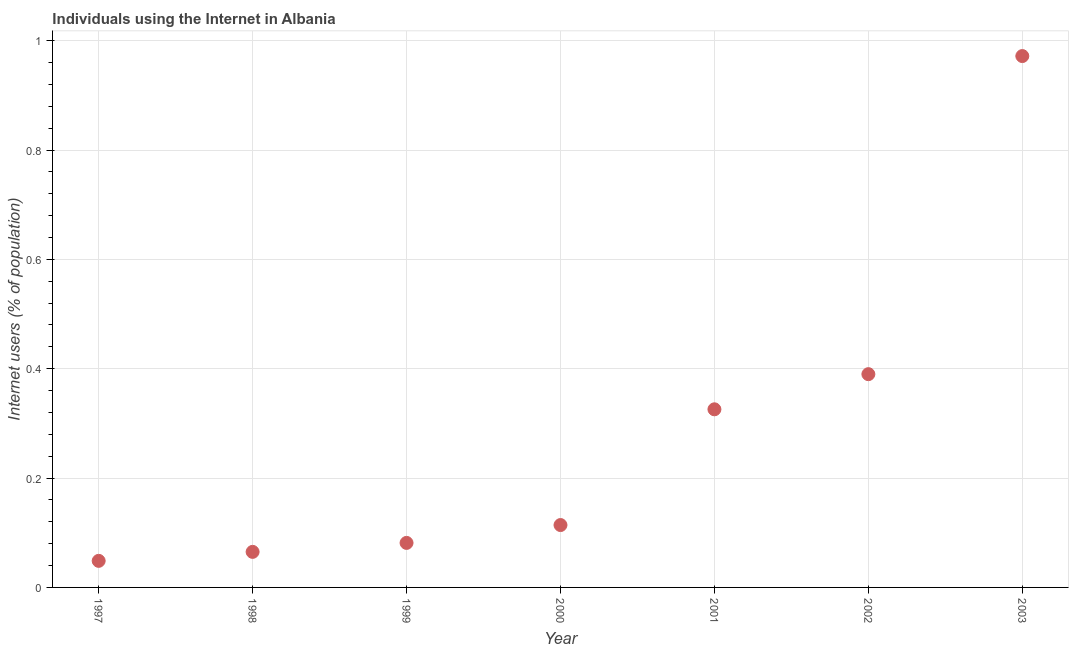What is the number of internet users in 1997?
Your answer should be compact. 0.05. Across all years, what is the maximum number of internet users?
Keep it short and to the point. 0.97. Across all years, what is the minimum number of internet users?
Offer a terse response. 0.05. In which year was the number of internet users maximum?
Provide a short and direct response. 2003. What is the sum of the number of internet users?
Keep it short and to the point. 2. What is the difference between the number of internet users in 1998 and 2001?
Give a very brief answer. -0.26. What is the average number of internet users per year?
Provide a short and direct response. 0.29. What is the median number of internet users?
Offer a very short reply. 0.11. Do a majority of the years between 1998 and 1997 (inclusive) have number of internet users greater than 0.04 %?
Your response must be concise. No. What is the ratio of the number of internet users in 2000 to that in 2001?
Your answer should be very brief. 0.35. Is the difference between the number of internet users in 1997 and 2002 greater than the difference between any two years?
Your answer should be very brief. No. What is the difference between the highest and the second highest number of internet users?
Ensure brevity in your answer.  0.58. What is the difference between the highest and the lowest number of internet users?
Give a very brief answer. 0.92. In how many years, is the number of internet users greater than the average number of internet users taken over all years?
Ensure brevity in your answer.  3. How many dotlines are there?
Your answer should be compact. 1. What is the title of the graph?
Keep it short and to the point. Individuals using the Internet in Albania. What is the label or title of the X-axis?
Make the answer very short. Year. What is the label or title of the Y-axis?
Offer a very short reply. Internet users (% of population). What is the Internet users (% of population) in 1997?
Keep it short and to the point. 0.05. What is the Internet users (% of population) in 1998?
Ensure brevity in your answer.  0.07. What is the Internet users (% of population) in 1999?
Provide a succinct answer. 0.08. What is the Internet users (% of population) in 2000?
Your response must be concise. 0.11. What is the Internet users (% of population) in 2001?
Provide a short and direct response. 0.33. What is the Internet users (% of population) in 2002?
Provide a succinct answer. 0.39. What is the Internet users (% of population) in 2003?
Provide a succinct answer. 0.97. What is the difference between the Internet users (% of population) in 1997 and 1998?
Ensure brevity in your answer.  -0.02. What is the difference between the Internet users (% of population) in 1997 and 1999?
Provide a succinct answer. -0.03. What is the difference between the Internet users (% of population) in 1997 and 2000?
Your response must be concise. -0.07. What is the difference between the Internet users (% of population) in 1997 and 2001?
Keep it short and to the point. -0.28. What is the difference between the Internet users (% of population) in 1997 and 2002?
Provide a succinct answer. -0.34. What is the difference between the Internet users (% of population) in 1997 and 2003?
Provide a short and direct response. -0.92. What is the difference between the Internet users (% of population) in 1998 and 1999?
Offer a terse response. -0.02. What is the difference between the Internet users (% of population) in 1998 and 2000?
Your answer should be very brief. -0.05. What is the difference between the Internet users (% of population) in 1998 and 2001?
Provide a succinct answer. -0.26. What is the difference between the Internet users (% of population) in 1998 and 2002?
Keep it short and to the point. -0.33. What is the difference between the Internet users (% of population) in 1998 and 2003?
Provide a succinct answer. -0.91. What is the difference between the Internet users (% of population) in 1999 and 2000?
Make the answer very short. -0.03. What is the difference between the Internet users (% of population) in 1999 and 2001?
Provide a short and direct response. -0.24. What is the difference between the Internet users (% of population) in 1999 and 2002?
Provide a short and direct response. -0.31. What is the difference between the Internet users (% of population) in 1999 and 2003?
Ensure brevity in your answer.  -0.89. What is the difference between the Internet users (% of population) in 2000 and 2001?
Your answer should be compact. -0.21. What is the difference between the Internet users (% of population) in 2000 and 2002?
Your answer should be compact. -0.28. What is the difference between the Internet users (% of population) in 2000 and 2003?
Provide a succinct answer. -0.86. What is the difference between the Internet users (% of population) in 2001 and 2002?
Your answer should be compact. -0.06. What is the difference between the Internet users (% of population) in 2001 and 2003?
Provide a succinct answer. -0.65. What is the difference between the Internet users (% of population) in 2002 and 2003?
Provide a short and direct response. -0.58. What is the ratio of the Internet users (% of population) in 1997 to that in 1998?
Provide a short and direct response. 0.75. What is the ratio of the Internet users (% of population) in 1997 to that in 1999?
Provide a short and direct response. 0.6. What is the ratio of the Internet users (% of population) in 1997 to that in 2000?
Offer a very short reply. 0.43. What is the ratio of the Internet users (% of population) in 1997 to that in 2001?
Provide a short and direct response. 0.15. What is the ratio of the Internet users (% of population) in 1997 to that in 2002?
Your response must be concise. 0.12. What is the ratio of the Internet users (% of population) in 1998 to that in 1999?
Give a very brief answer. 0.8. What is the ratio of the Internet users (% of population) in 1998 to that in 2000?
Provide a short and direct response. 0.57. What is the ratio of the Internet users (% of population) in 1998 to that in 2002?
Your response must be concise. 0.17. What is the ratio of the Internet users (% of population) in 1998 to that in 2003?
Your answer should be very brief. 0.07. What is the ratio of the Internet users (% of population) in 1999 to that in 2000?
Make the answer very short. 0.71. What is the ratio of the Internet users (% of population) in 1999 to that in 2001?
Provide a succinct answer. 0.25. What is the ratio of the Internet users (% of population) in 1999 to that in 2002?
Offer a very short reply. 0.21. What is the ratio of the Internet users (% of population) in 1999 to that in 2003?
Your answer should be compact. 0.08. What is the ratio of the Internet users (% of population) in 2000 to that in 2001?
Give a very brief answer. 0.35. What is the ratio of the Internet users (% of population) in 2000 to that in 2002?
Keep it short and to the point. 0.29. What is the ratio of the Internet users (% of population) in 2000 to that in 2003?
Your response must be concise. 0.12. What is the ratio of the Internet users (% of population) in 2001 to that in 2002?
Offer a very short reply. 0.83. What is the ratio of the Internet users (% of population) in 2001 to that in 2003?
Your answer should be very brief. 0.34. What is the ratio of the Internet users (% of population) in 2002 to that in 2003?
Your answer should be compact. 0.4. 